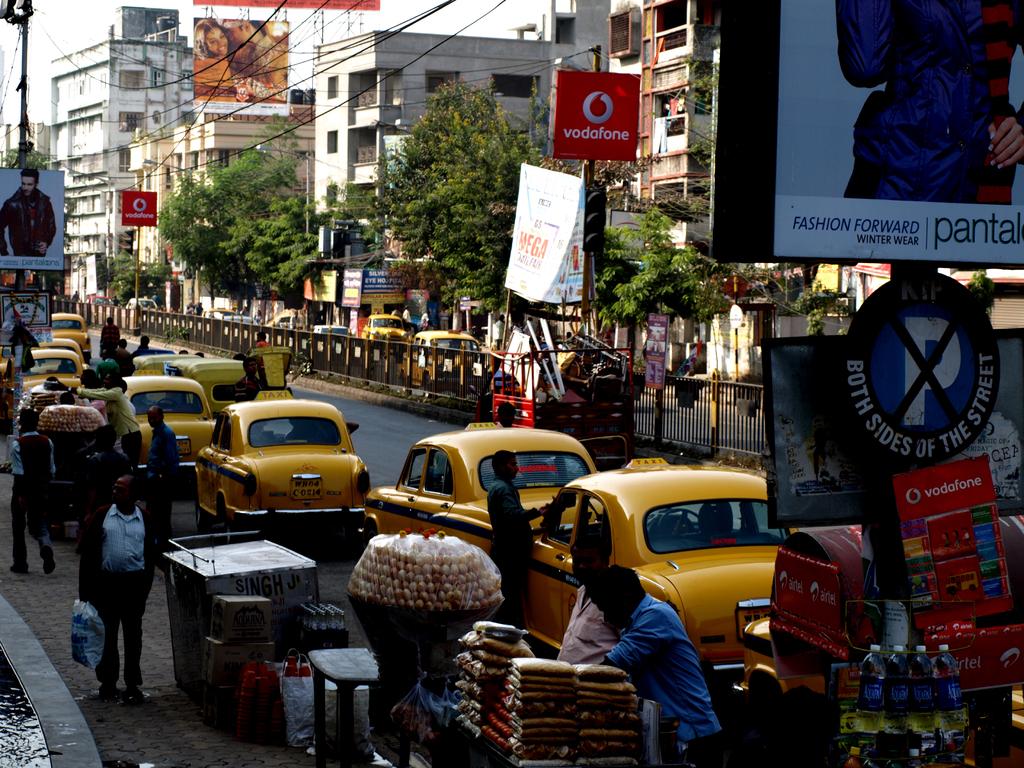Can you park on either side of the street?
Your answer should be very brief. No. Is the parking full?
Offer a terse response. Answering does not require reading text in the image. 